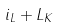<formula> <loc_0><loc_0><loc_500><loc_500>i _ { L } + L _ { K }</formula> 